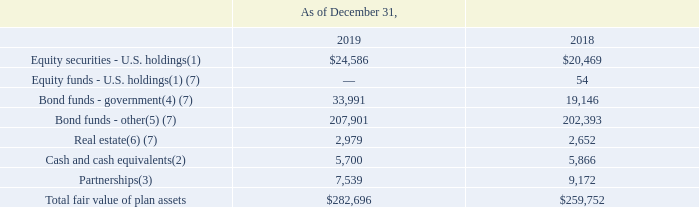NOTES TO CONSOLIDATED FINANCIAL STATEMENTS (in thousands, except for share and per share data)
We employ a liability-driven investment strategy whereby a mix of equity and fixed-income investments are used to pursue a derisking strategy which over time seeks to reduce interest rate mismatch risk and other risks while achieving a return that matches or exceeds the growth in projected pension plan liabilities. Risk tolerance is established through careful consideration of plan liabilities and funded status. The investment portfolio primarily contains a diversified mix of equity and fixed-income investments. Other assets such as private equity are used modestly to enhance long-term returns while improving portfolio diversification. Investment risk is measured and monitored on an ongoing basis through quarterly investment portfolio reviews, annual liability measurements, and asset/liability studies at regular intervals.
The following table summarizes the fair values of our pension plan assets:
(1) Comprised of common stocks of companies in various industries. The Pension Plan fund manager may shift investments from value to growth strategies or vice-versa, from small cap to large cap stocks or vice-versa, in order to meet the Pension Plan's investment objectives, which are to provide for a reasonable amount of long-term growth of capital without undue exposure to volatility, and protect the assets from erosion of purchasing power.
(2) Comprised of investment grade short-term investment and money-market funds.
(3) Comprised of partnerships that invest in various U.S. and international industries.
(4) Comprised of long-term government bonds with a minimum maturity of 10 years and zero-coupon Treasury securities ("Treasury Strips") with maturities greater than 20 years.
(5) Comprised predominately of investment grade U.S. corporate bonds with maturities greater than 10 years and U.S. high-yield corporate bonds; emerging market debt (local currency sovereign bonds, U.S. dollar-denominated sovereign bonds and U.S. dollar-denominated corporate bonds); and U.S. bank loans.
(6) Comprised of investments in securities of U.S. and non-U.S. real estate investment trusts (REITs), real estate operating companies and other companies that are principally engaged in the real estate industry and of investments in global private direct commercial real estate. Investments can be redeemed immediately following the valuation date with a notice of at least fifteen business days before valuation.
(7) Comprised of investments that are measured at fair value using the NAV per share practical expedient. In accordance with the provisions of ASC 820-10, these investments have not been classified in the fair value hierarchy. The fair value amount not leveled is presented to allow reconciliation of the fair value hierarchy to total fund pension plan assets.
Which years does the table provide information for the fair values of the company's pension plan assets? 2019, 2018. What were the Equity securities - U.S. holdings in 2018?
Answer scale should be: thousand. 20,469. What was the amount of Other bond funds in 2019?
Answer scale should be: thousand. 207,901. What was the change in Real Estate between 2018 and 2019?
Answer scale should be: thousand. 2,979-2,652
Answer: 327. What was the change in the government bond funds between 2018 and 2019?
Answer scale should be: thousand. 33,991-19,146
Answer: 14845. What was the percentage change in Partnerships between 2018 and 2019?
Answer scale should be: percent. (7,539-9,172)/9,172
Answer: -17.8. 